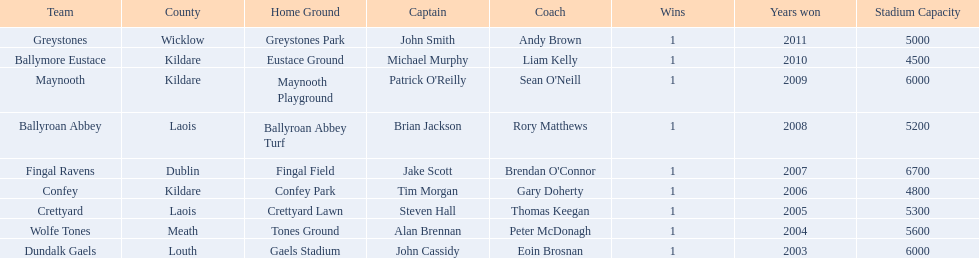What county is ballymore eustace from? Kildare. Besides convey, which other team is from the same county? Maynooth. 